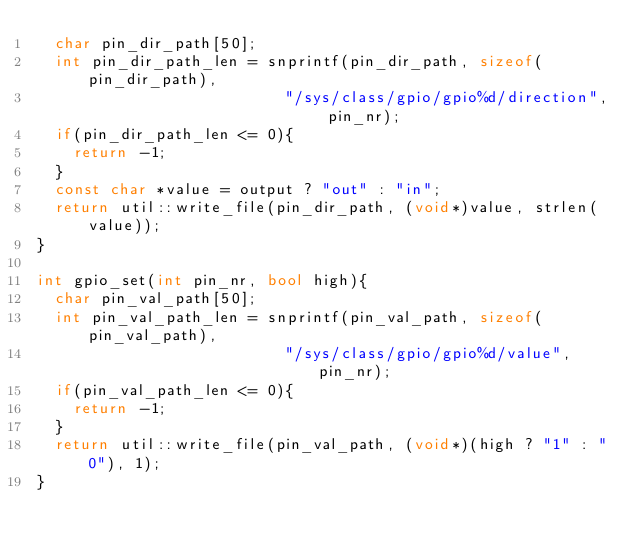Convert code to text. <code><loc_0><loc_0><loc_500><loc_500><_C++_>  char pin_dir_path[50];
  int pin_dir_path_len = snprintf(pin_dir_path, sizeof(pin_dir_path),
                           "/sys/class/gpio/gpio%d/direction", pin_nr);
  if(pin_dir_path_len <= 0){
    return -1;
  }
  const char *value = output ? "out" : "in";
  return util::write_file(pin_dir_path, (void*)value, strlen(value));
}

int gpio_set(int pin_nr, bool high){
  char pin_val_path[50];
  int pin_val_path_len = snprintf(pin_val_path, sizeof(pin_val_path),
                           "/sys/class/gpio/gpio%d/value", pin_nr);
  if(pin_val_path_len <= 0){
    return -1;
  }
  return util::write_file(pin_val_path, (void*)(high ? "1" : "0"), 1);
}
</code> 